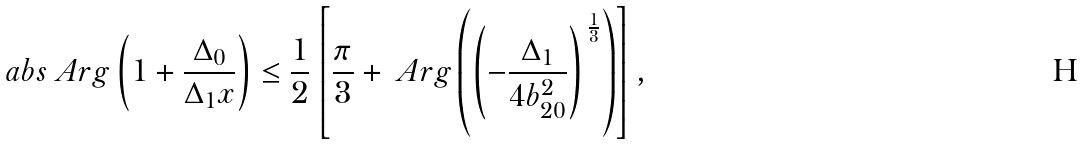Convert formula to latex. <formula><loc_0><loc_0><loc_500><loc_500>\ a b s { \ A r g \left ( 1 + \frac { \Delta _ { 0 } } { \Delta _ { 1 } x } \right ) } \leq \frac { 1 } { 2 } \left [ \frac { \pi } { 3 } + \ A r g \left ( \left ( - \frac { \Delta _ { 1 } } { 4 b _ { 2 0 } ^ { 2 } } \right ) ^ { \, \frac { 1 } { 3 } } \right ) \right ] ,</formula> 